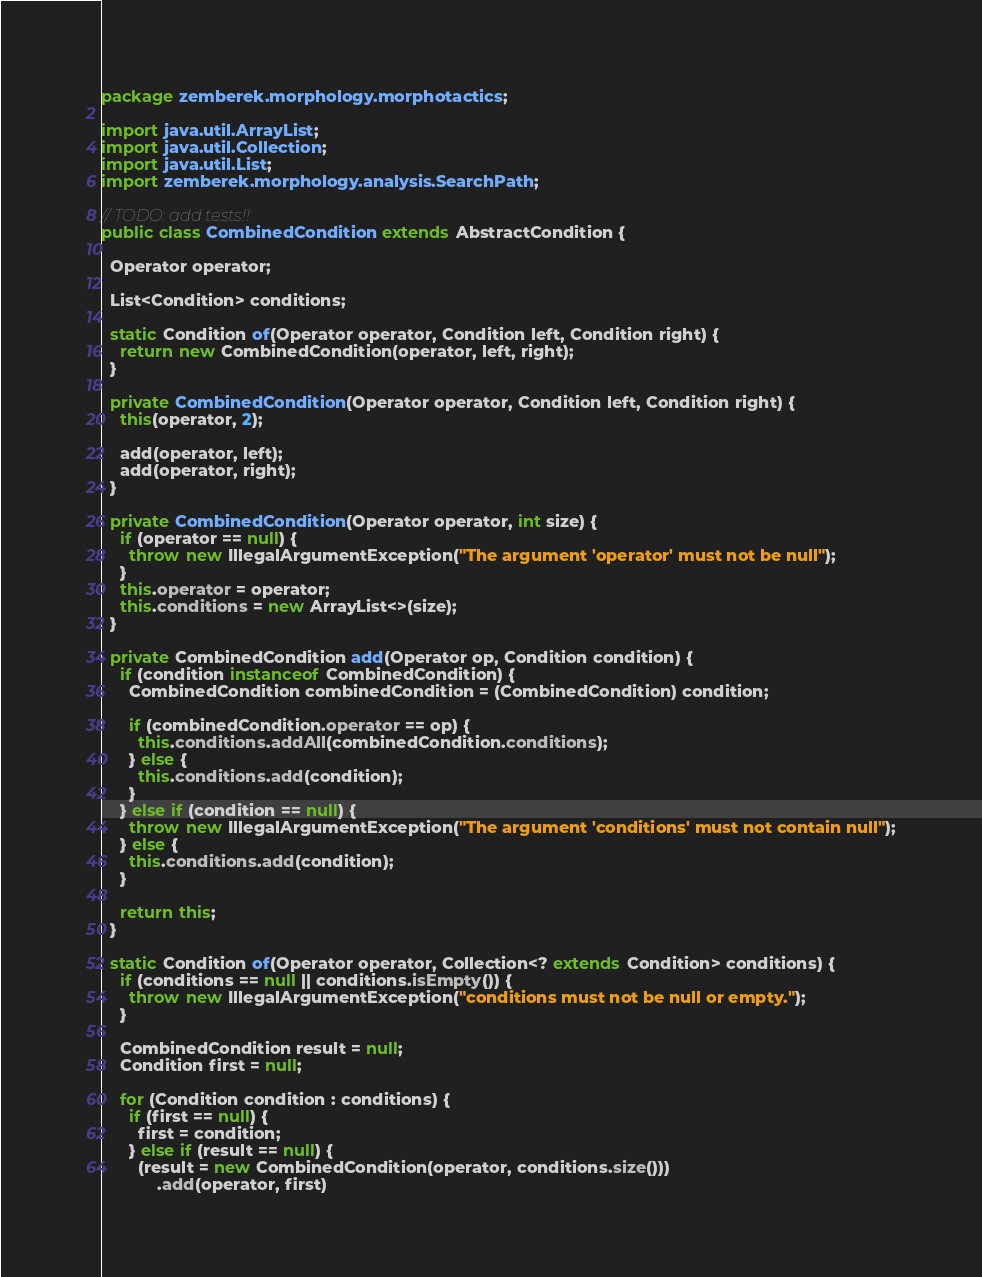<code> <loc_0><loc_0><loc_500><loc_500><_Java_>package zemberek.morphology.morphotactics;

import java.util.ArrayList;
import java.util.Collection;
import java.util.List;
import zemberek.morphology.analysis.SearchPath;

// TODO: add tests!!
public class CombinedCondition extends AbstractCondition {

  Operator operator;

  List<Condition> conditions;

  static Condition of(Operator operator, Condition left, Condition right) {
    return new CombinedCondition(operator, left, right);
  }

  private CombinedCondition(Operator operator, Condition left, Condition right) {
    this(operator, 2);

    add(operator, left);
    add(operator, right);
  }

  private CombinedCondition(Operator operator, int size) {
    if (operator == null) {
      throw new IllegalArgumentException("The argument 'operator' must not be null");
    }
    this.operator = operator;
    this.conditions = new ArrayList<>(size);
  }

  private CombinedCondition add(Operator op, Condition condition) {
    if (condition instanceof CombinedCondition) {
      CombinedCondition combinedCondition = (CombinedCondition) condition;

      if (combinedCondition.operator == op) {
        this.conditions.addAll(combinedCondition.conditions);
      } else {
        this.conditions.add(condition);
      }
    } else if (condition == null) {
      throw new IllegalArgumentException("The argument 'conditions' must not contain null");
    } else {
      this.conditions.add(condition);
    }

    return this;
  }

  static Condition of(Operator operator, Collection<? extends Condition> conditions) {
    if (conditions == null || conditions.isEmpty()) {
      throw new IllegalArgumentException("conditions must not be null or empty.");
    }

    CombinedCondition result = null;
    Condition first = null;

    for (Condition condition : conditions) {
      if (first == null) {
        first = condition;
      } else if (result == null) {
        (result = new CombinedCondition(operator, conditions.size()))
            .add(operator, first)</code> 